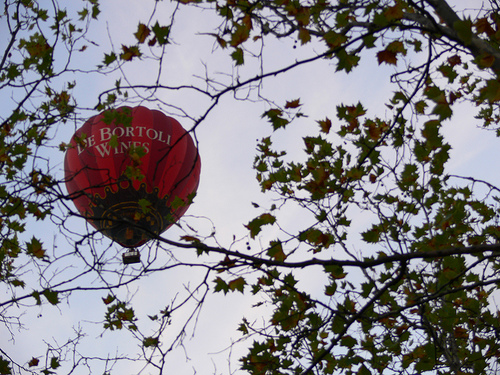<image>
Is there a balloon in the sky? Yes. The balloon is contained within or inside the sky, showing a containment relationship. 